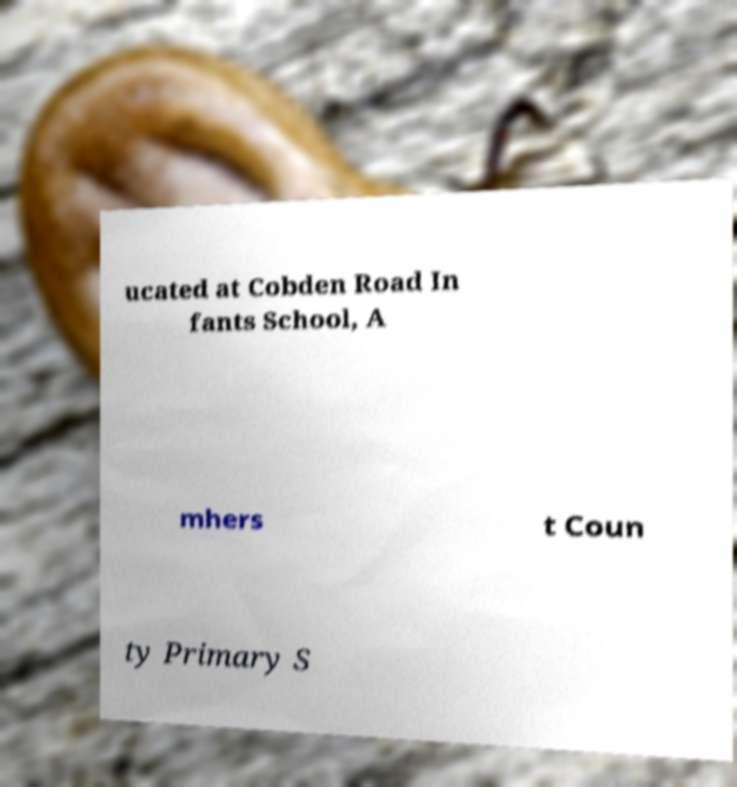For documentation purposes, I need the text within this image transcribed. Could you provide that? ucated at Cobden Road In fants School, A mhers t Coun ty Primary S 